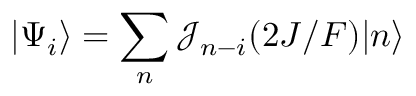<formula> <loc_0><loc_0><loc_500><loc_500>| \Psi _ { i } \rangle = \sum _ { n } \mathcal { J } _ { n - i } ( 2 J / F ) | n \rangle</formula> 